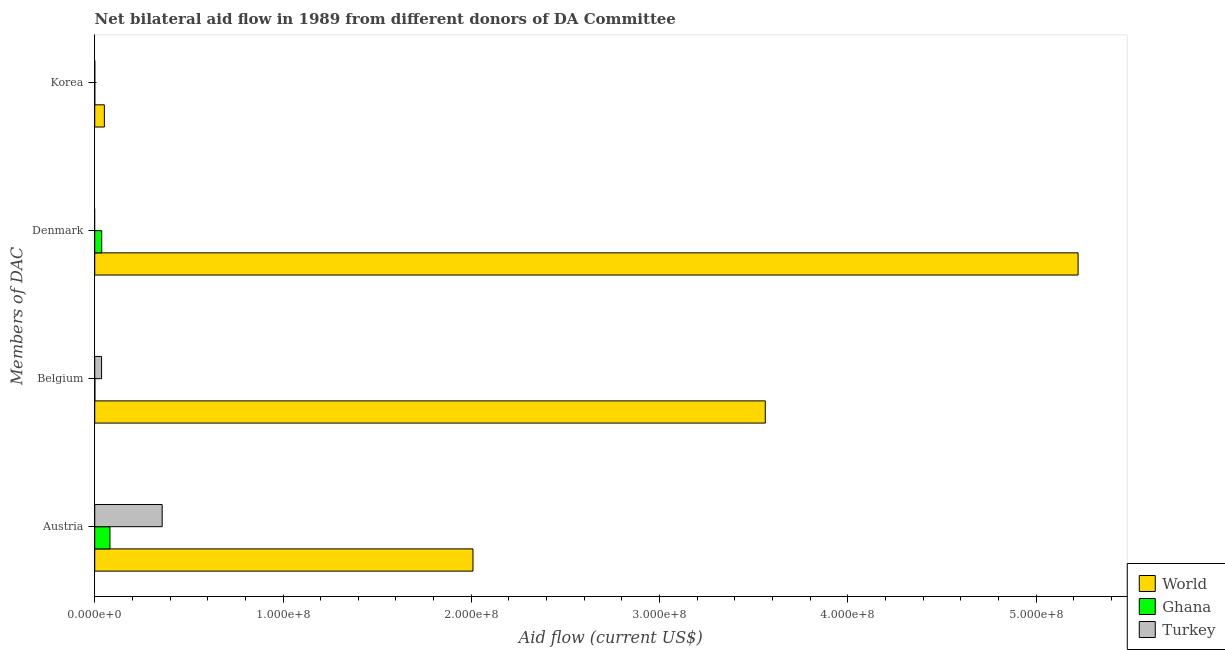How many different coloured bars are there?
Offer a very short reply. 3. How many groups of bars are there?
Your answer should be very brief. 4. What is the label of the 3rd group of bars from the top?
Your response must be concise. Belgium. What is the amount of aid given by korea in Ghana?
Keep it short and to the point. 2.00e+04. Across all countries, what is the maximum amount of aid given by denmark?
Your response must be concise. 5.22e+08. Across all countries, what is the minimum amount of aid given by korea?
Ensure brevity in your answer.  10000. What is the total amount of aid given by denmark in the graph?
Ensure brevity in your answer.  5.26e+08. What is the difference between the amount of aid given by belgium in Ghana and that in World?
Keep it short and to the point. -3.56e+08. What is the difference between the amount of aid given by austria in Turkey and the amount of aid given by korea in World?
Offer a very short reply. 3.07e+07. What is the average amount of aid given by belgium per country?
Make the answer very short. 1.20e+08. What is the difference between the amount of aid given by belgium and amount of aid given by korea in World?
Provide a succinct answer. 3.51e+08. In how many countries, is the amount of aid given by korea greater than 20000000 US$?
Your answer should be compact. 0. What is the ratio of the amount of aid given by belgium in Ghana to that in Turkey?
Provide a short and direct response. 0.02. Is the difference between the amount of aid given by belgium in Turkey and Ghana greater than the difference between the amount of aid given by korea in Turkey and Ghana?
Ensure brevity in your answer.  Yes. What is the difference between the highest and the second highest amount of aid given by austria?
Make the answer very short. 1.65e+08. What is the difference between the highest and the lowest amount of aid given by austria?
Ensure brevity in your answer.  1.93e+08. In how many countries, is the amount of aid given by belgium greater than the average amount of aid given by belgium taken over all countries?
Offer a terse response. 1. Is the sum of the amount of aid given by austria in World and Ghana greater than the maximum amount of aid given by korea across all countries?
Your answer should be very brief. Yes. Is it the case that in every country, the sum of the amount of aid given by austria and amount of aid given by belgium is greater than the amount of aid given by denmark?
Keep it short and to the point. Yes. How many legend labels are there?
Give a very brief answer. 3. How are the legend labels stacked?
Provide a short and direct response. Vertical. What is the title of the graph?
Provide a succinct answer. Net bilateral aid flow in 1989 from different donors of DA Committee. Does "Nicaragua" appear as one of the legend labels in the graph?
Offer a very short reply. No. What is the label or title of the X-axis?
Keep it short and to the point. Aid flow (current US$). What is the label or title of the Y-axis?
Your answer should be very brief. Members of DAC. What is the Aid flow (current US$) of World in Austria?
Your answer should be very brief. 2.01e+08. What is the Aid flow (current US$) in Ghana in Austria?
Keep it short and to the point. 8.09e+06. What is the Aid flow (current US$) of Turkey in Austria?
Give a very brief answer. 3.58e+07. What is the Aid flow (current US$) of World in Belgium?
Your response must be concise. 3.56e+08. What is the Aid flow (current US$) of Turkey in Belgium?
Keep it short and to the point. 3.64e+06. What is the Aid flow (current US$) of World in Denmark?
Offer a very short reply. 5.22e+08. What is the Aid flow (current US$) in Ghana in Denmark?
Your answer should be compact. 3.70e+06. What is the Aid flow (current US$) in World in Korea?
Your answer should be very brief. 5.11e+06. What is the Aid flow (current US$) in Ghana in Korea?
Offer a very short reply. 2.00e+04. What is the Aid flow (current US$) of Turkey in Korea?
Provide a short and direct response. 10000. Across all Members of DAC, what is the maximum Aid flow (current US$) of World?
Make the answer very short. 5.22e+08. Across all Members of DAC, what is the maximum Aid flow (current US$) of Ghana?
Make the answer very short. 8.09e+06. Across all Members of DAC, what is the maximum Aid flow (current US$) of Turkey?
Your response must be concise. 3.58e+07. Across all Members of DAC, what is the minimum Aid flow (current US$) in World?
Your answer should be compact. 5.11e+06. Across all Members of DAC, what is the minimum Aid flow (current US$) of Ghana?
Keep it short and to the point. 2.00e+04. What is the total Aid flow (current US$) of World in the graph?
Make the answer very short. 1.08e+09. What is the total Aid flow (current US$) of Ghana in the graph?
Offer a terse response. 1.19e+07. What is the total Aid flow (current US$) in Turkey in the graph?
Provide a short and direct response. 3.95e+07. What is the difference between the Aid flow (current US$) in World in Austria and that in Belgium?
Give a very brief answer. -1.55e+08. What is the difference between the Aid flow (current US$) of Ghana in Austria and that in Belgium?
Provide a succinct answer. 8.01e+06. What is the difference between the Aid flow (current US$) in Turkey in Austria and that in Belgium?
Your answer should be very brief. 3.22e+07. What is the difference between the Aid flow (current US$) of World in Austria and that in Denmark?
Ensure brevity in your answer.  -3.21e+08. What is the difference between the Aid flow (current US$) in Ghana in Austria and that in Denmark?
Offer a very short reply. 4.39e+06. What is the difference between the Aid flow (current US$) of World in Austria and that in Korea?
Keep it short and to the point. 1.96e+08. What is the difference between the Aid flow (current US$) in Ghana in Austria and that in Korea?
Your answer should be very brief. 8.07e+06. What is the difference between the Aid flow (current US$) of Turkey in Austria and that in Korea?
Keep it short and to the point. 3.58e+07. What is the difference between the Aid flow (current US$) of World in Belgium and that in Denmark?
Offer a terse response. -1.66e+08. What is the difference between the Aid flow (current US$) of Ghana in Belgium and that in Denmark?
Give a very brief answer. -3.62e+06. What is the difference between the Aid flow (current US$) of World in Belgium and that in Korea?
Offer a terse response. 3.51e+08. What is the difference between the Aid flow (current US$) of Turkey in Belgium and that in Korea?
Your answer should be very brief. 3.63e+06. What is the difference between the Aid flow (current US$) in World in Denmark and that in Korea?
Your answer should be very brief. 5.17e+08. What is the difference between the Aid flow (current US$) in Ghana in Denmark and that in Korea?
Keep it short and to the point. 3.68e+06. What is the difference between the Aid flow (current US$) in World in Austria and the Aid flow (current US$) in Ghana in Belgium?
Offer a terse response. 2.01e+08. What is the difference between the Aid flow (current US$) of World in Austria and the Aid flow (current US$) of Turkey in Belgium?
Offer a terse response. 1.97e+08. What is the difference between the Aid flow (current US$) in Ghana in Austria and the Aid flow (current US$) in Turkey in Belgium?
Keep it short and to the point. 4.45e+06. What is the difference between the Aid flow (current US$) of World in Austria and the Aid flow (current US$) of Ghana in Denmark?
Provide a short and direct response. 1.97e+08. What is the difference between the Aid flow (current US$) in World in Austria and the Aid flow (current US$) in Ghana in Korea?
Your response must be concise. 2.01e+08. What is the difference between the Aid flow (current US$) of World in Austria and the Aid flow (current US$) of Turkey in Korea?
Provide a succinct answer. 2.01e+08. What is the difference between the Aid flow (current US$) in Ghana in Austria and the Aid flow (current US$) in Turkey in Korea?
Make the answer very short. 8.08e+06. What is the difference between the Aid flow (current US$) of World in Belgium and the Aid flow (current US$) of Ghana in Denmark?
Provide a succinct answer. 3.52e+08. What is the difference between the Aid flow (current US$) in World in Belgium and the Aid flow (current US$) in Ghana in Korea?
Give a very brief answer. 3.56e+08. What is the difference between the Aid flow (current US$) in World in Belgium and the Aid flow (current US$) in Turkey in Korea?
Keep it short and to the point. 3.56e+08. What is the difference between the Aid flow (current US$) of World in Denmark and the Aid flow (current US$) of Ghana in Korea?
Your answer should be very brief. 5.22e+08. What is the difference between the Aid flow (current US$) in World in Denmark and the Aid flow (current US$) in Turkey in Korea?
Offer a terse response. 5.22e+08. What is the difference between the Aid flow (current US$) of Ghana in Denmark and the Aid flow (current US$) of Turkey in Korea?
Give a very brief answer. 3.69e+06. What is the average Aid flow (current US$) in World per Members of DAC?
Make the answer very short. 2.71e+08. What is the average Aid flow (current US$) of Ghana per Members of DAC?
Your answer should be very brief. 2.97e+06. What is the average Aid flow (current US$) in Turkey per Members of DAC?
Give a very brief answer. 9.87e+06. What is the difference between the Aid flow (current US$) of World and Aid flow (current US$) of Ghana in Austria?
Offer a terse response. 1.93e+08. What is the difference between the Aid flow (current US$) in World and Aid flow (current US$) in Turkey in Austria?
Provide a short and direct response. 1.65e+08. What is the difference between the Aid flow (current US$) in Ghana and Aid flow (current US$) in Turkey in Austria?
Provide a succinct answer. -2.77e+07. What is the difference between the Aid flow (current US$) of World and Aid flow (current US$) of Ghana in Belgium?
Your answer should be very brief. 3.56e+08. What is the difference between the Aid flow (current US$) of World and Aid flow (current US$) of Turkey in Belgium?
Provide a short and direct response. 3.53e+08. What is the difference between the Aid flow (current US$) in Ghana and Aid flow (current US$) in Turkey in Belgium?
Ensure brevity in your answer.  -3.56e+06. What is the difference between the Aid flow (current US$) in World and Aid flow (current US$) in Ghana in Denmark?
Give a very brief answer. 5.19e+08. What is the difference between the Aid flow (current US$) of World and Aid flow (current US$) of Ghana in Korea?
Give a very brief answer. 5.09e+06. What is the difference between the Aid flow (current US$) in World and Aid flow (current US$) in Turkey in Korea?
Offer a terse response. 5.10e+06. What is the difference between the Aid flow (current US$) of Ghana and Aid flow (current US$) of Turkey in Korea?
Provide a short and direct response. 10000. What is the ratio of the Aid flow (current US$) of World in Austria to that in Belgium?
Provide a short and direct response. 0.56. What is the ratio of the Aid flow (current US$) in Ghana in Austria to that in Belgium?
Provide a succinct answer. 101.12. What is the ratio of the Aid flow (current US$) in Turkey in Austria to that in Belgium?
Ensure brevity in your answer.  9.84. What is the ratio of the Aid flow (current US$) in World in Austria to that in Denmark?
Make the answer very short. 0.38. What is the ratio of the Aid flow (current US$) in Ghana in Austria to that in Denmark?
Your answer should be very brief. 2.19. What is the ratio of the Aid flow (current US$) in World in Austria to that in Korea?
Your response must be concise. 39.32. What is the ratio of the Aid flow (current US$) of Ghana in Austria to that in Korea?
Make the answer very short. 404.5. What is the ratio of the Aid flow (current US$) of Turkey in Austria to that in Korea?
Offer a terse response. 3582. What is the ratio of the Aid flow (current US$) in World in Belgium to that in Denmark?
Offer a very short reply. 0.68. What is the ratio of the Aid flow (current US$) in Ghana in Belgium to that in Denmark?
Provide a succinct answer. 0.02. What is the ratio of the Aid flow (current US$) of World in Belgium to that in Korea?
Keep it short and to the point. 69.7. What is the ratio of the Aid flow (current US$) of Turkey in Belgium to that in Korea?
Give a very brief answer. 364. What is the ratio of the Aid flow (current US$) in World in Denmark to that in Korea?
Offer a terse response. 102.22. What is the ratio of the Aid flow (current US$) in Ghana in Denmark to that in Korea?
Your answer should be compact. 185. What is the difference between the highest and the second highest Aid flow (current US$) in World?
Your answer should be compact. 1.66e+08. What is the difference between the highest and the second highest Aid flow (current US$) in Ghana?
Your answer should be compact. 4.39e+06. What is the difference between the highest and the second highest Aid flow (current US$) of Turkey?
Give a very brief answer. 3.22e+07. What is the difference between the highest and the lowest Aid flow (current US$) in World?
Offer a very short reply. 5.17e+08. What is the difference between the highest and the lowest Aid flow (current US$) of Ghana?
Provide a short and direct response. 8.07e+06. What is the difference between the highest and the lowest Aid flow (current US$) of Turkey?
Provide a succinct answer. 3.58e+07. 